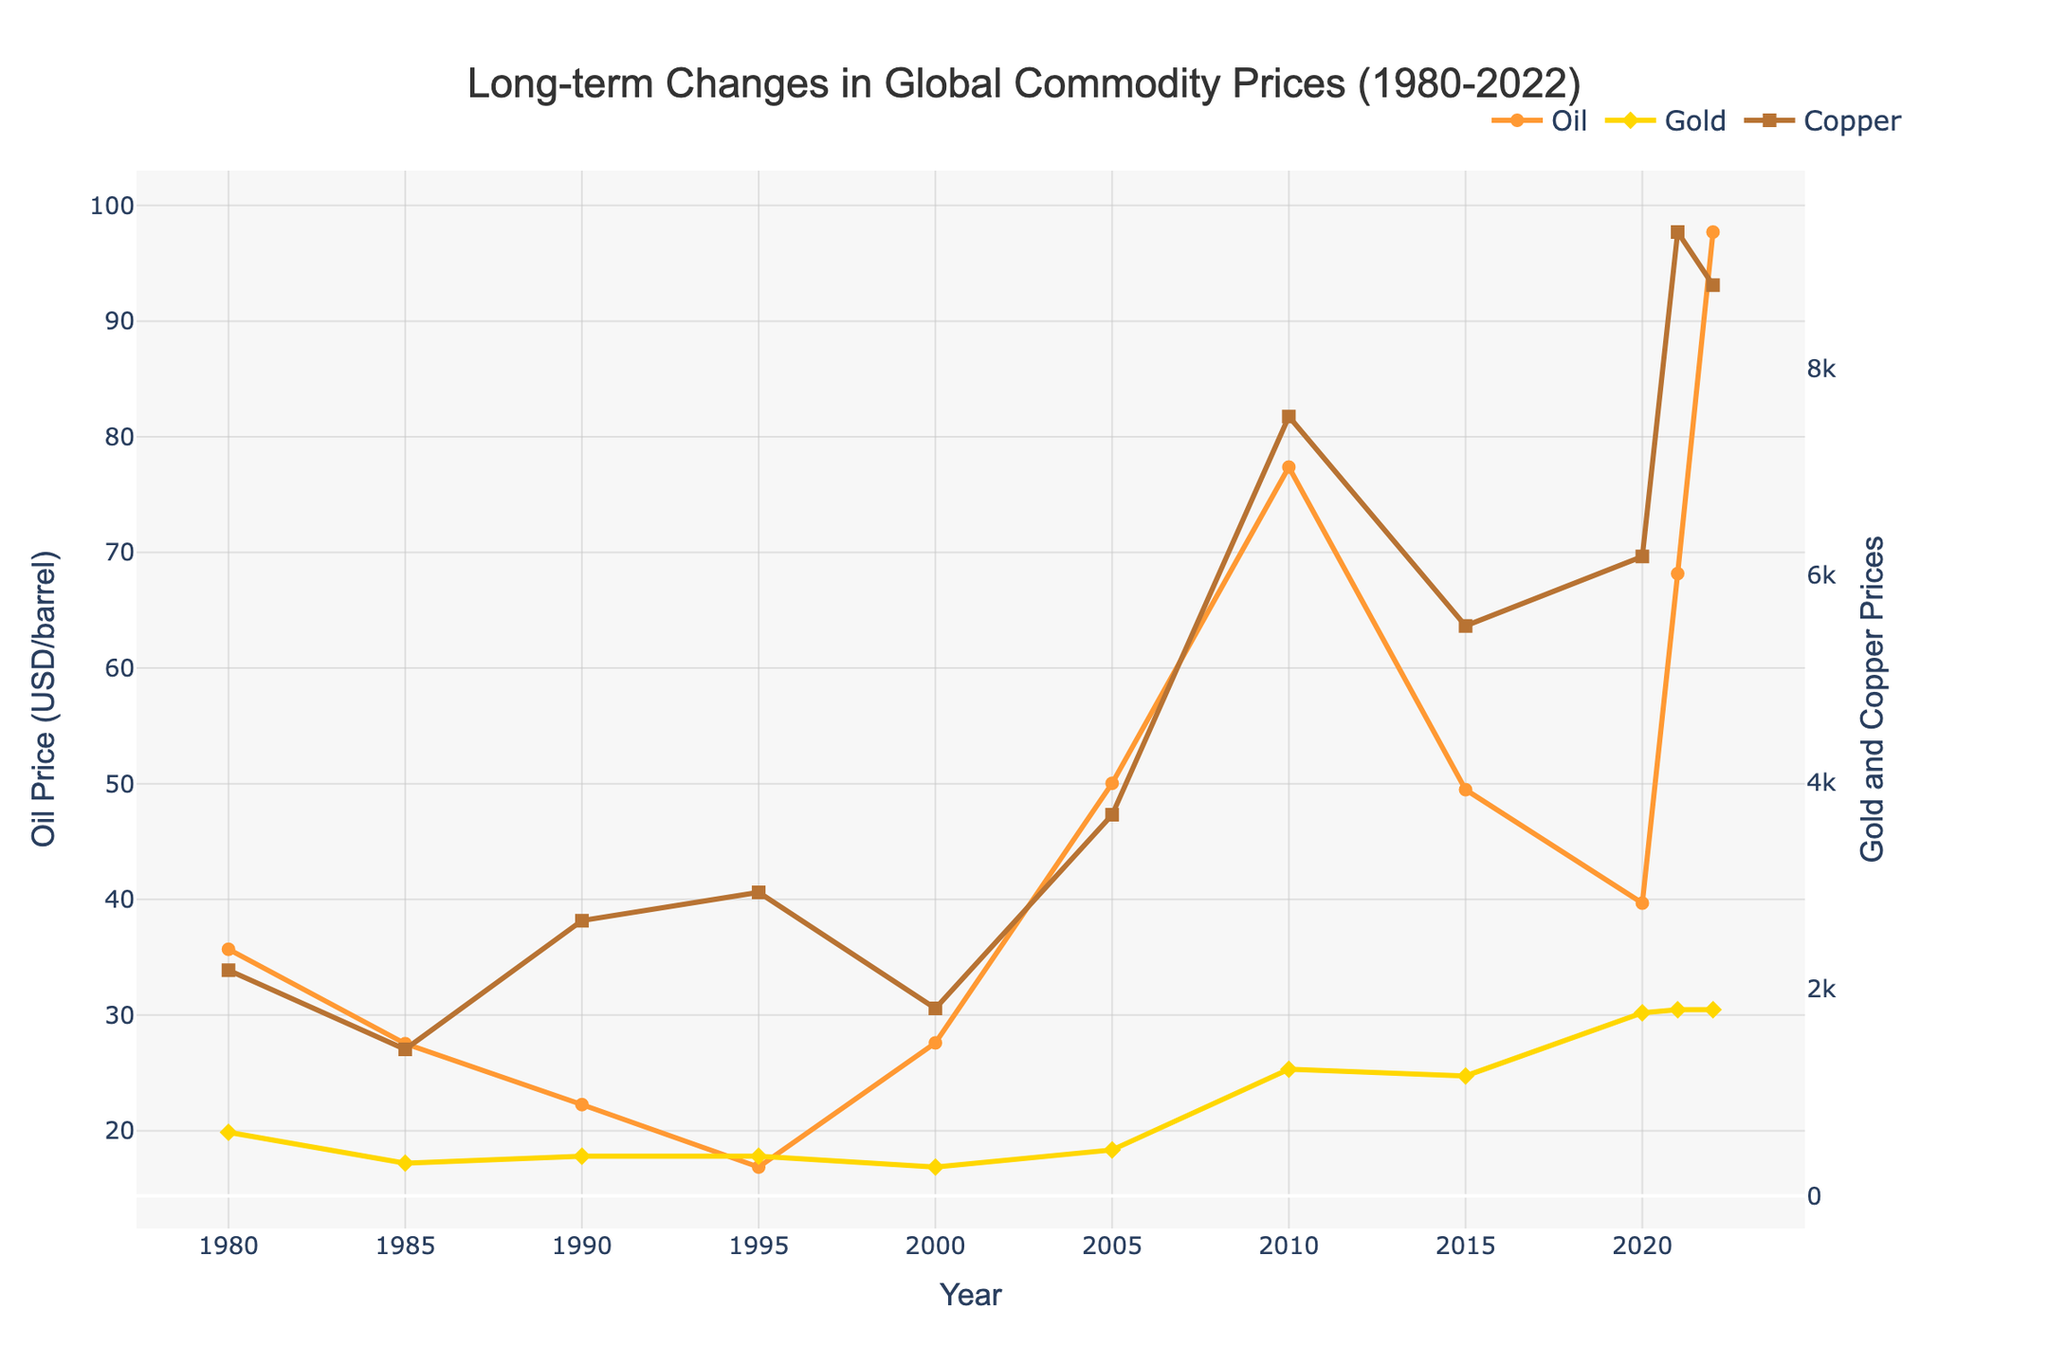what trends can be observed from the oil prices between 1980 and 2022? The oil prices fluctuated substantially over the years. Starting at about 35.69 USD/barrel in 1980, the price decreased to a low of around 16.86 USD/barrel in 1995. Following this, oil prices rose considerably, reaching a peak around 97.70 USD/barrel in 2022.
Answer: Fluctuated substantially with an increase after 1995 When did the price of gold experience its most significant rise? Observing the gold price line, the most significant rise can be seen between 2000 and 2010, changing from around 279.11 USD/oz in 2000 to about 1224.52 USD/oz in 2010.
Answer: 2000 to 2010 How does the trend in copper prices compare between 2000 and 2022? From the figure, copper prices increased from around 1813 USD/tonne in 2000 to a peak of approximately 7534 USD/tonne in 2010, then fluctuating before reaching about 8804 USD/tonne in 2022. Overall, the trend shows a notable increase.
Answer: Notable increase with fluctuations Which year shows the highest price for oil, gold, and copper respectively? For oil, the highest price is observed in 2022 at 97.70 USD/barrel. For gold, it is around 1800.09 USD/oz in 2022. For copper, it also peaks at 9317 USD/tonne in 2021.
Answer: 2022 for oil, 2022 for gold, 2021 for copper What is the difference in gold prices between 2000 and 2022? The price of gold in 2000 was 279.11 USD/oz, and it increased to 1800.09 USD/oz in 2022. The difference is calculated as 1800.09 - 279.11, which is 1520.98 USD/oz.
Answer: 1520.98 USD/oz Compare the price change percentage of oil and copper from 1980 to 2022. In 1980, oil was 35.69 USD/barrel and increased to 97.70 USD/barrel in 2022. The percentage change for oil is ((97.70 - 35.69) / 35.69) * 100 ≈ 173.78%. For copper, starting at 2182 USD/tonne in 1980 and reaching 8804 USD/tonne in 2022, the percentage change is ((8804 - 2182) / 2182) * 100 ≈ 303.45%.
Answer: 173.78% for oil, 303.45% for copper How did the prices of oil, gold, and copper change during 2000-2015? From the graph, oil prices rose from 27.60 USD/barrel in 2000 to 50.04 USD/barrel in 2005, peaking at 77.38 USD/barrel in 2010, and then dropping to 49.49 USD/barrel in 2015. Gold increased notably from 279.11 USD/oz in 2000 to a high of 1224.52 USD/oz in 2010, then slightly decreasing by 2015 to 1160.06 USD/oz. Copper rose significantly from 1813 USD/tonne in 2000 to 7534 USD/tonne in 2010 before decreasing to 5510 USD/tonne by 2015.
Answer: Increase and then decrease for all three Which commodity shows the most stable price trend over the observed period? By visually comparing the trends, gold appears to have more stable and gradual changes over the years compared to the more volatile movements in oil and copper prices.
Answer: Gold What's the average price of copper from 1980 to 2022? By summing up the recorded prices for each year and dividing by the number of years, the average price is (2182 + 1417 + 2661 + 2935 + 1813 + 3684 + 7534 + 5510 + 6181 + 9317 + 8804) / 11 ≈ 4811.
Answer: 4811 USD/tonne 